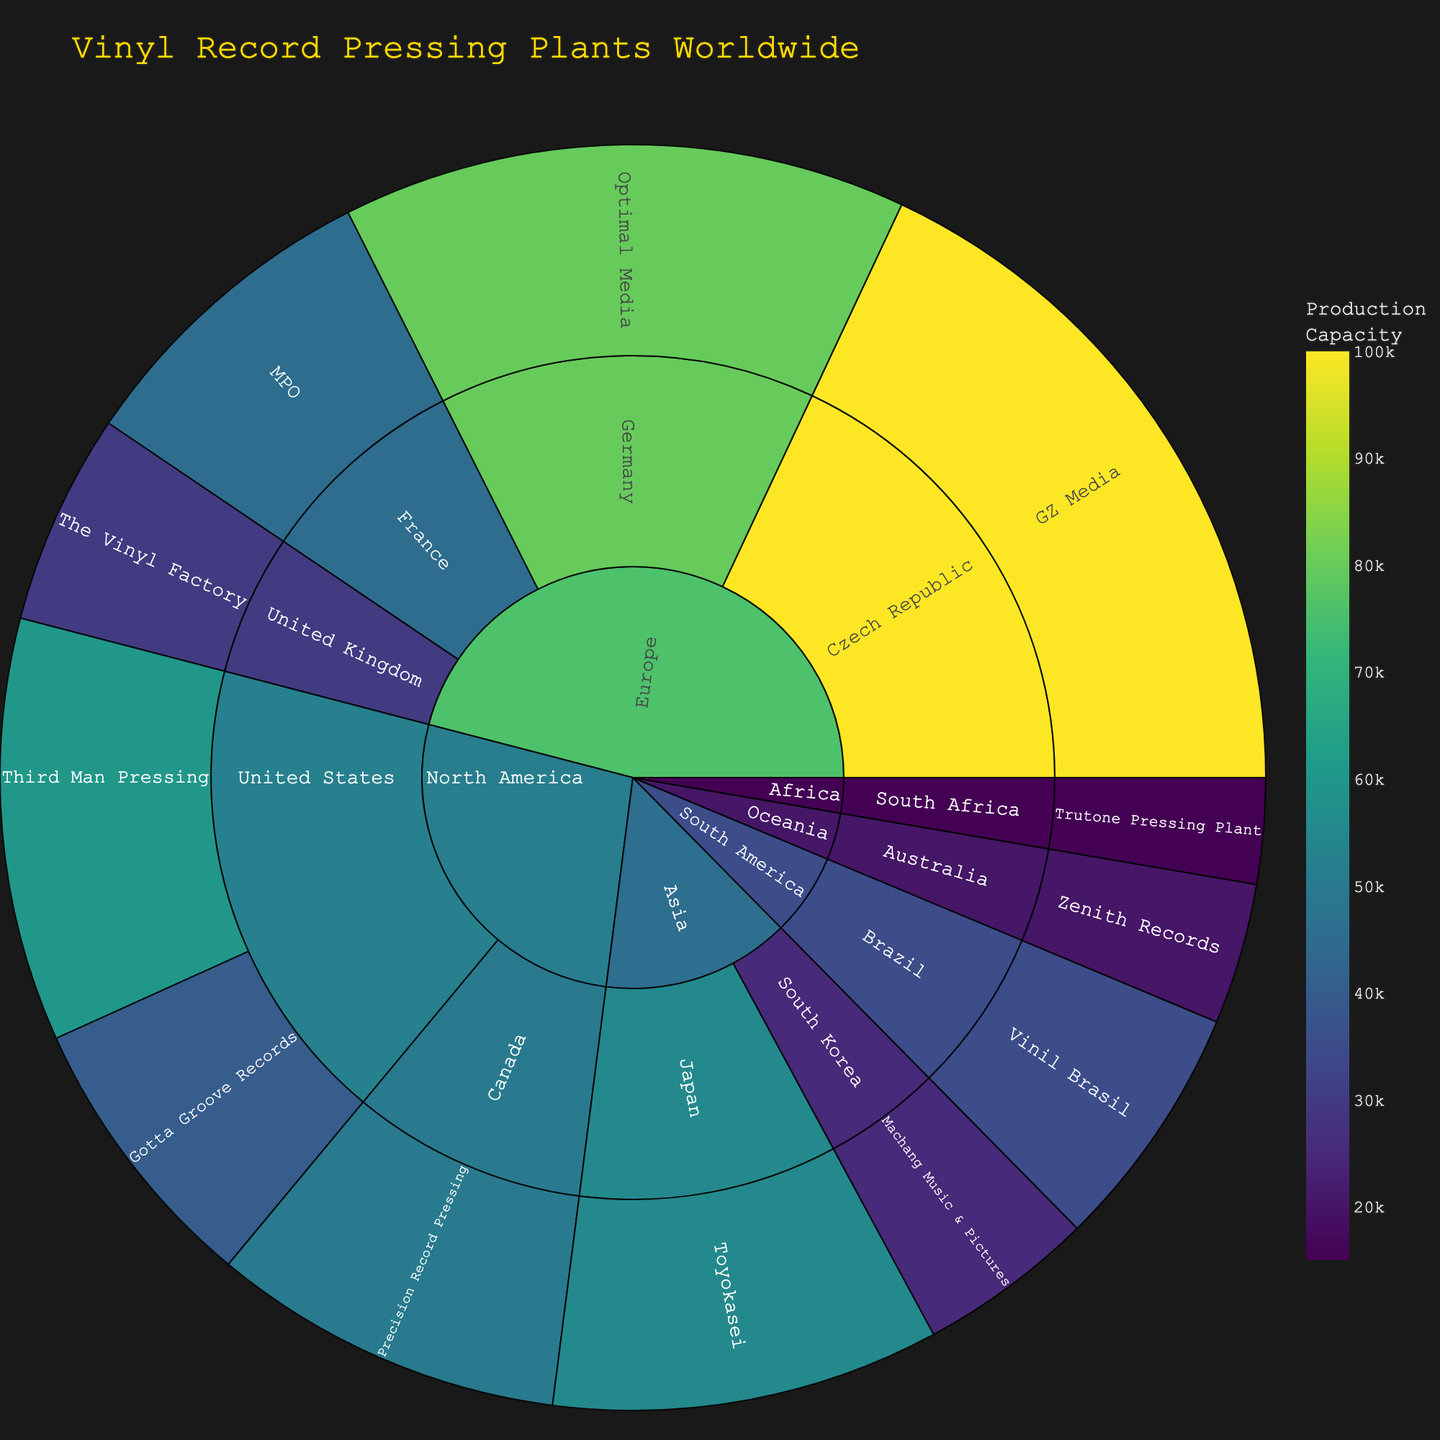What is the title of the figure? The title is displayed at the top of the figure. It provides the main context for the data being visualized.
Answer: Vinyl Record Pressing Plants Worldwide Which continent has the plant with the highest production capacity? The sunburst plot shows the hierarchy of data. By looking at the color intensity and labels, identify the plant with the highest capacity and trace it back to its continent.
Answer: Europe How many pressing plants are there in North America? In the sunburst plot, locate North America, and count the number of plants nested within it. Each segment representing a plant under North America must be counted.
Answer: 3 Which country in Europe has the most pressing plants? Locate Europe in the sunburst, and then count the number of segments for each country within Europe. The country with the most segments has the highest number of pressing plants.
Answer: Germany Which pressing plant in North America has the lowest production capacity? Find North America in the sunburst, check the capacity values for the plants within it, and identify the one with the lowest value.
Answer: Gotta Groove Records Which continent has the smallest number of pressing plants? Observe the sunburst plot and count the number of segments representing pressing plants within each continent. The continent with the fewest segments has the smallest number of plants.
Answer: Africa What is the approximate difference in production capacity between Optimal Media and GZ Media? Locate the segments for Optimal Media and GZ Media in the sunburst. Note their capacities and subtract the smaller from the larger (100000 - 80000).
Answer: 20000 